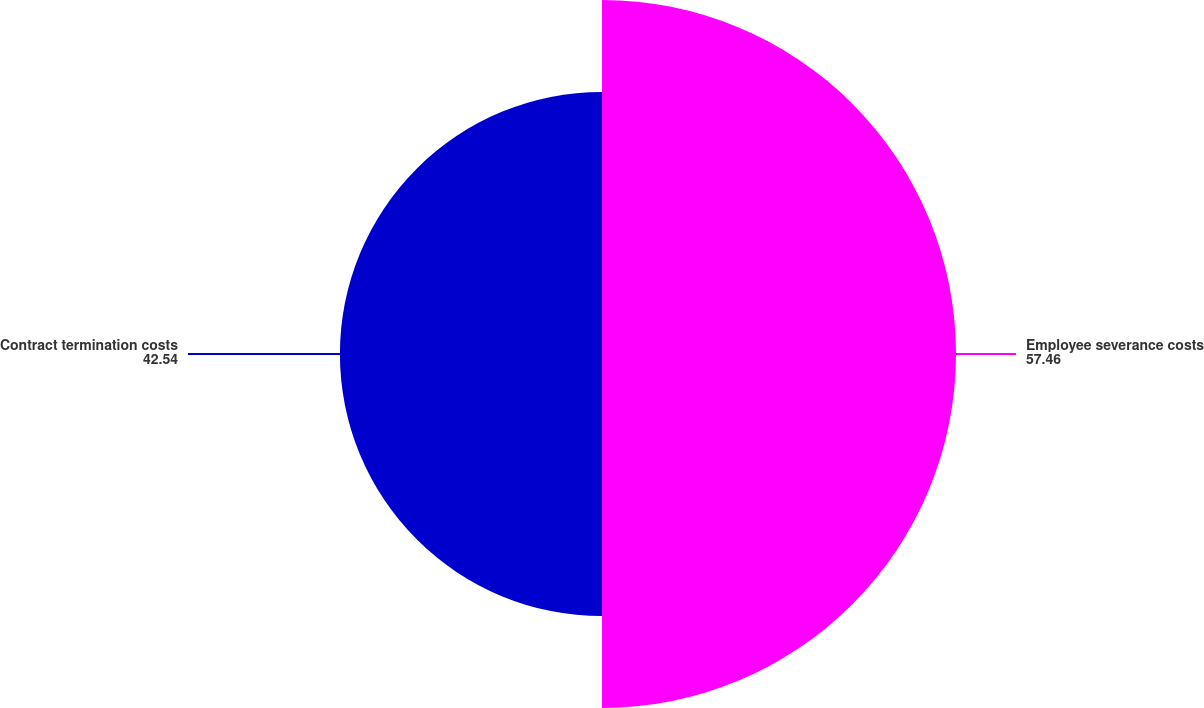Convert chart to OTSL. <chart><loc_0><loc_0><loc_500><loc_500><pie_chart><fcel>Employee severance costs<fcel>Contract termination costs<nl><fcel>57.46%<fcel>42.54%<nl></chart> 